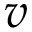Convert formula to latex. <formula><loc_0><loc_0><loc_500><loc_500>v</formula> 